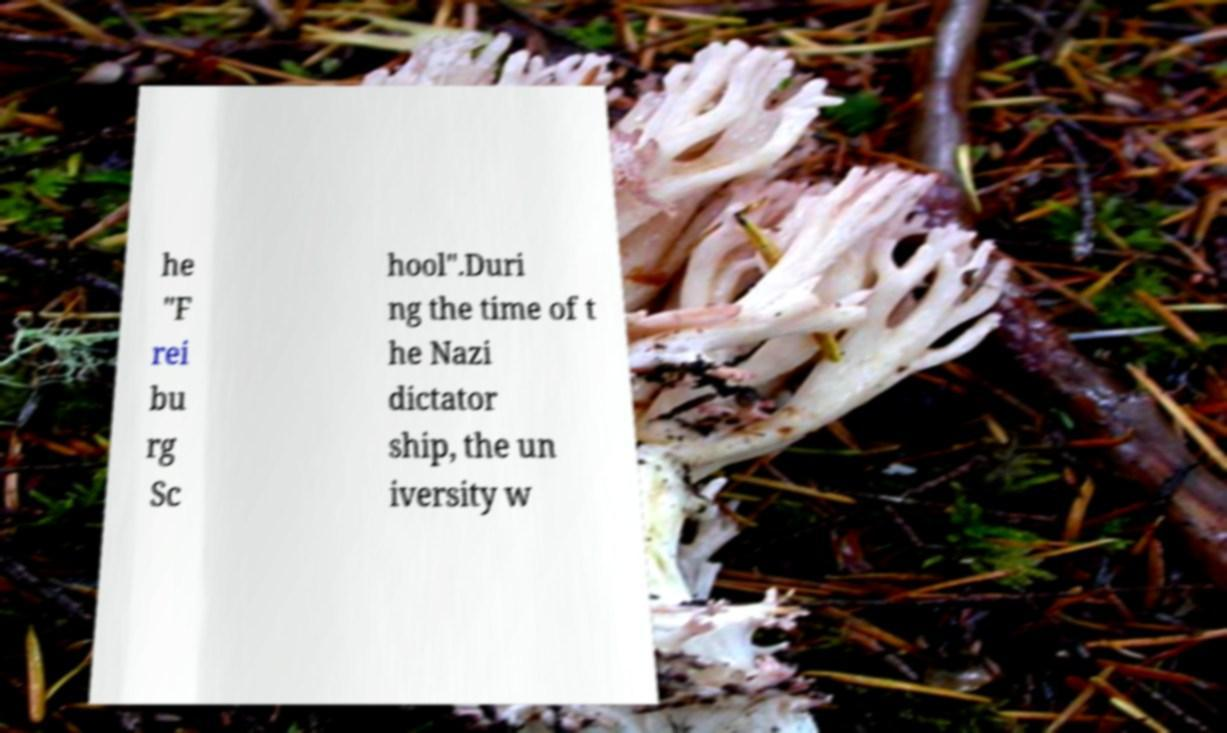Please read and relay the text visible in this image. What does it say? he "F rei bu rg Sc hool".Duri ng the time of t he Nazi dictator ship, the un iversity w 